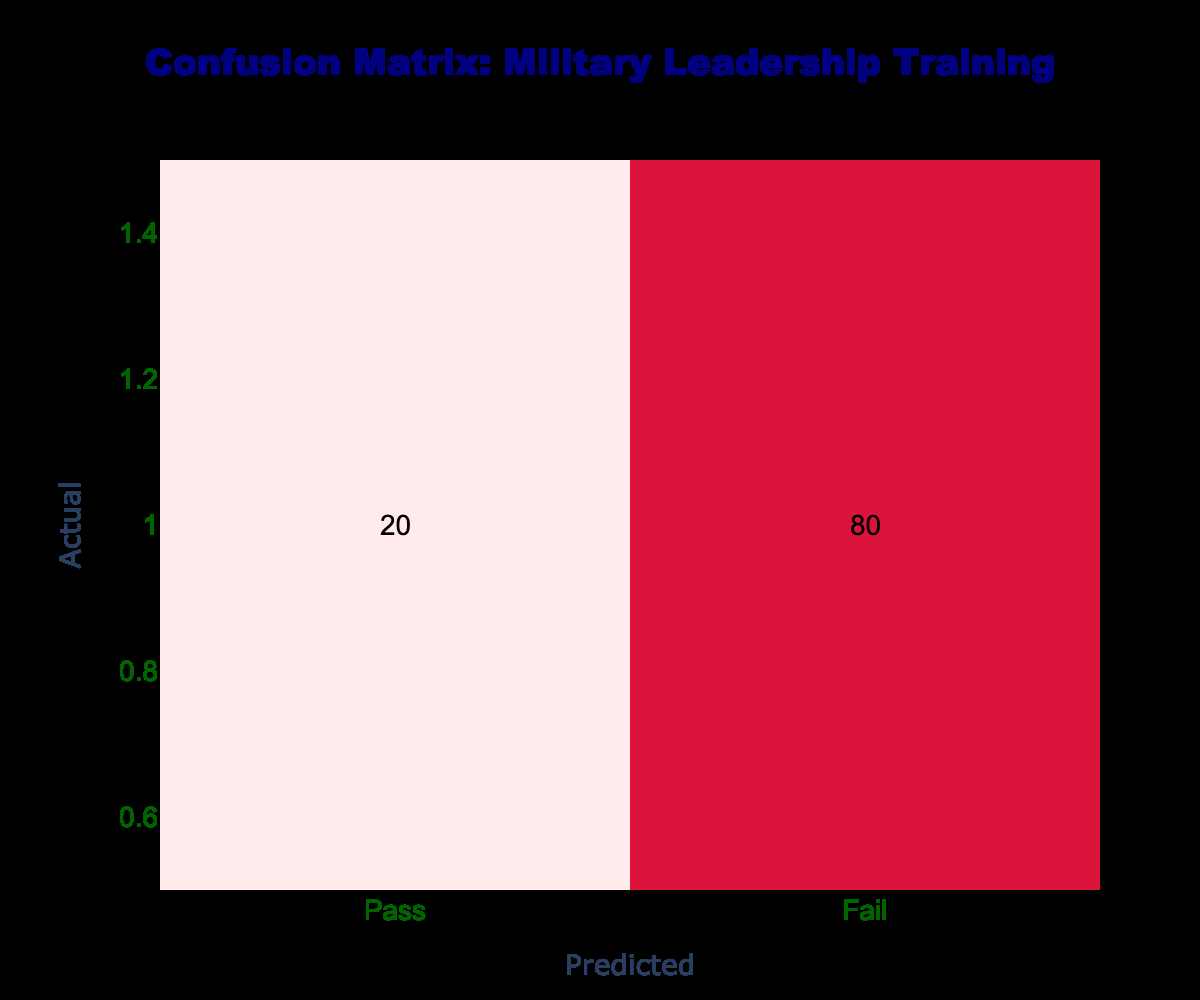What is the total number of students who passed the training program? To find the total number of students who passed, we look at the "Pass" row in the table. The value in the "Pass" column is 85, which indicates the number of students who passed the program.
Answer: 85 What is the total number of students who failed the training program? We examine the "Fail" row, where the value in the "Fail" column is 80. This indicates the number of students who failed the program.
Answer: 80 How many students were correctly predicted to pass? To find the number of students correctly predicted to pass, we refer to the "Pass" row and "Pass" column, where the value is 85. This represents students who actually passed and were predicted to pass.
Answer: 85 What is the accuracy of the military leadership training program based on this data? Accuracy is calculated by adding the true positives and true negatives and dividing by the total number of students. In this case, true positives (TP) = 85 and true negatives (TN) = 80, giving a total accuracy of (TP + TN) / total = (85 + 80) / (85 + 15 + 20 + 80) = 165 / 200 = 0.825. Thus, multiply by 100 for percentage: 82.5%.
Answer: 82.5% Is it true that more students passed the program than failed? To verify this, we compare the total number of students who passed (85) to those who failed (80). Since 85 > 80, the statement is true.
Answer: Yes How many students were incorrectly predicted to fail? This number is found by looking at the "Fail" row and "Pass" column, which indicates students who actually passed but were predicted to fail. The value is 15.
Answer: 15 What percentage of students failed the training program? To find the percentage of students who failed, we consider the number of students who failed (80) divided by the total number of students (200) and multiply by 100. The calculation is (80 / 200) * 100 = 40%.
Answer: 40% If 10 more students were expected to pass, how would that affect the accuracy? Currently, 85 students passed. If 10 more students pass, the number becomes 95, while the total number of students remains the same. The new accuracy would be calculated as (95 + 80) / (200) = 175 / 200 = 0.875, which is 87.5%.
Answer: 87.5% 